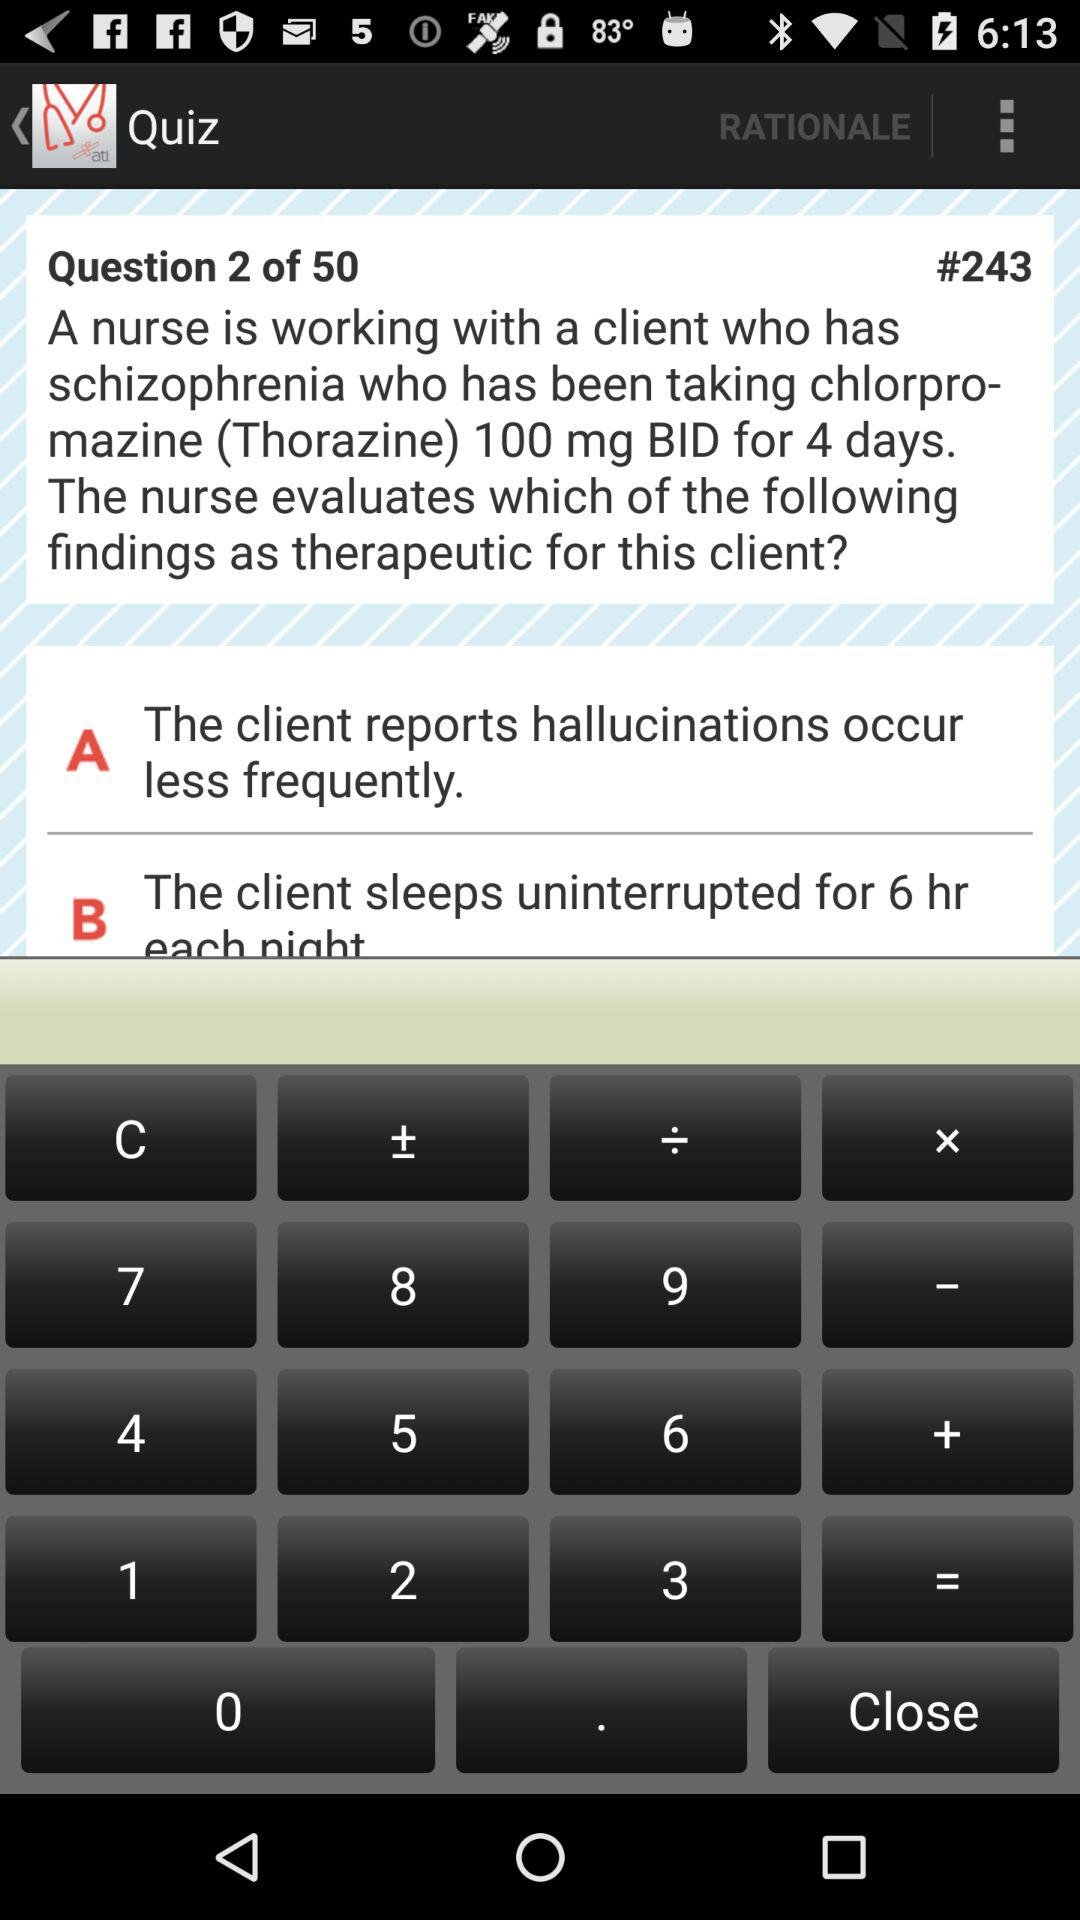What question number am I currently at? You are currently at question number 2. 